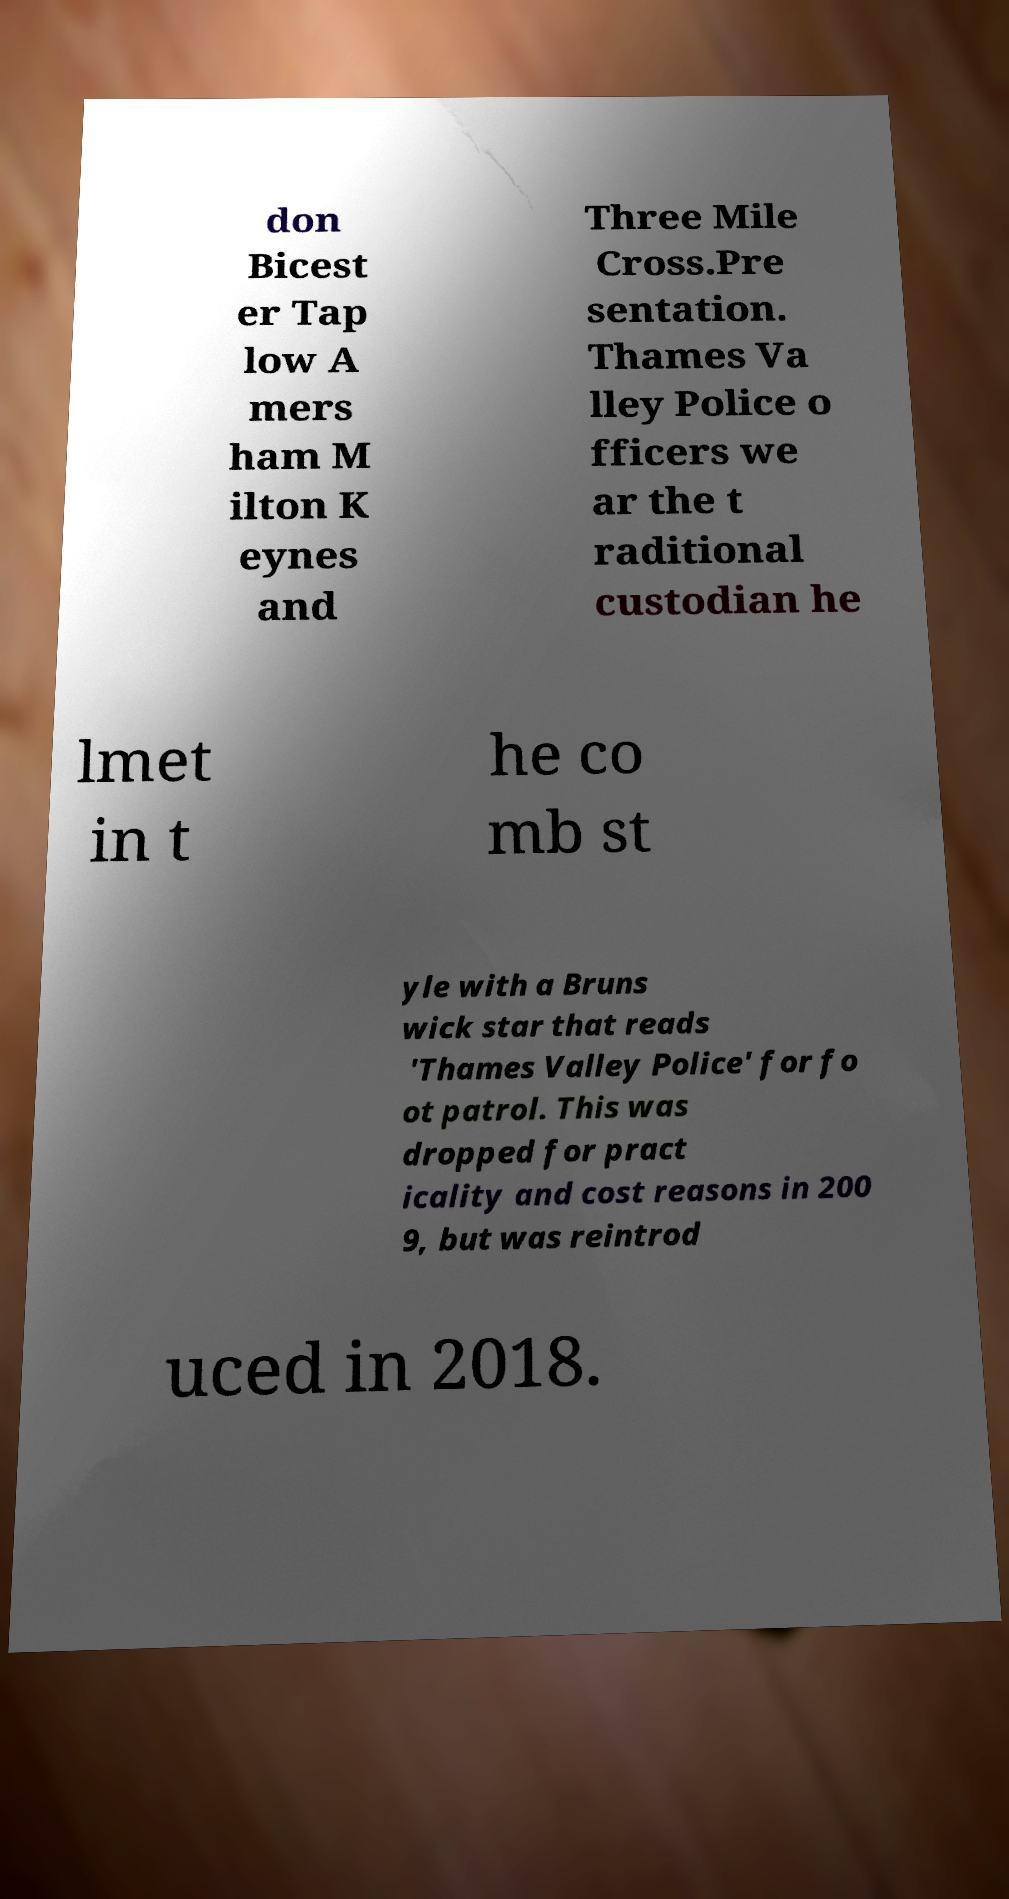Please read and relay the text visible in this image. What does it say? don Bicest er Tap low A mers ham M ilton K eynes and Three Mile Cross.Pre sentation. Thames Va lley Police o fficers we ar the t raditional custodian he lmet in t he co mb st yle with a Bruns wick star that reads 'Thames Valley Police' for fo ot patrol. This was dropped for pract icality and cost reasons in 200 9, but was reintrod uced in 2018. 